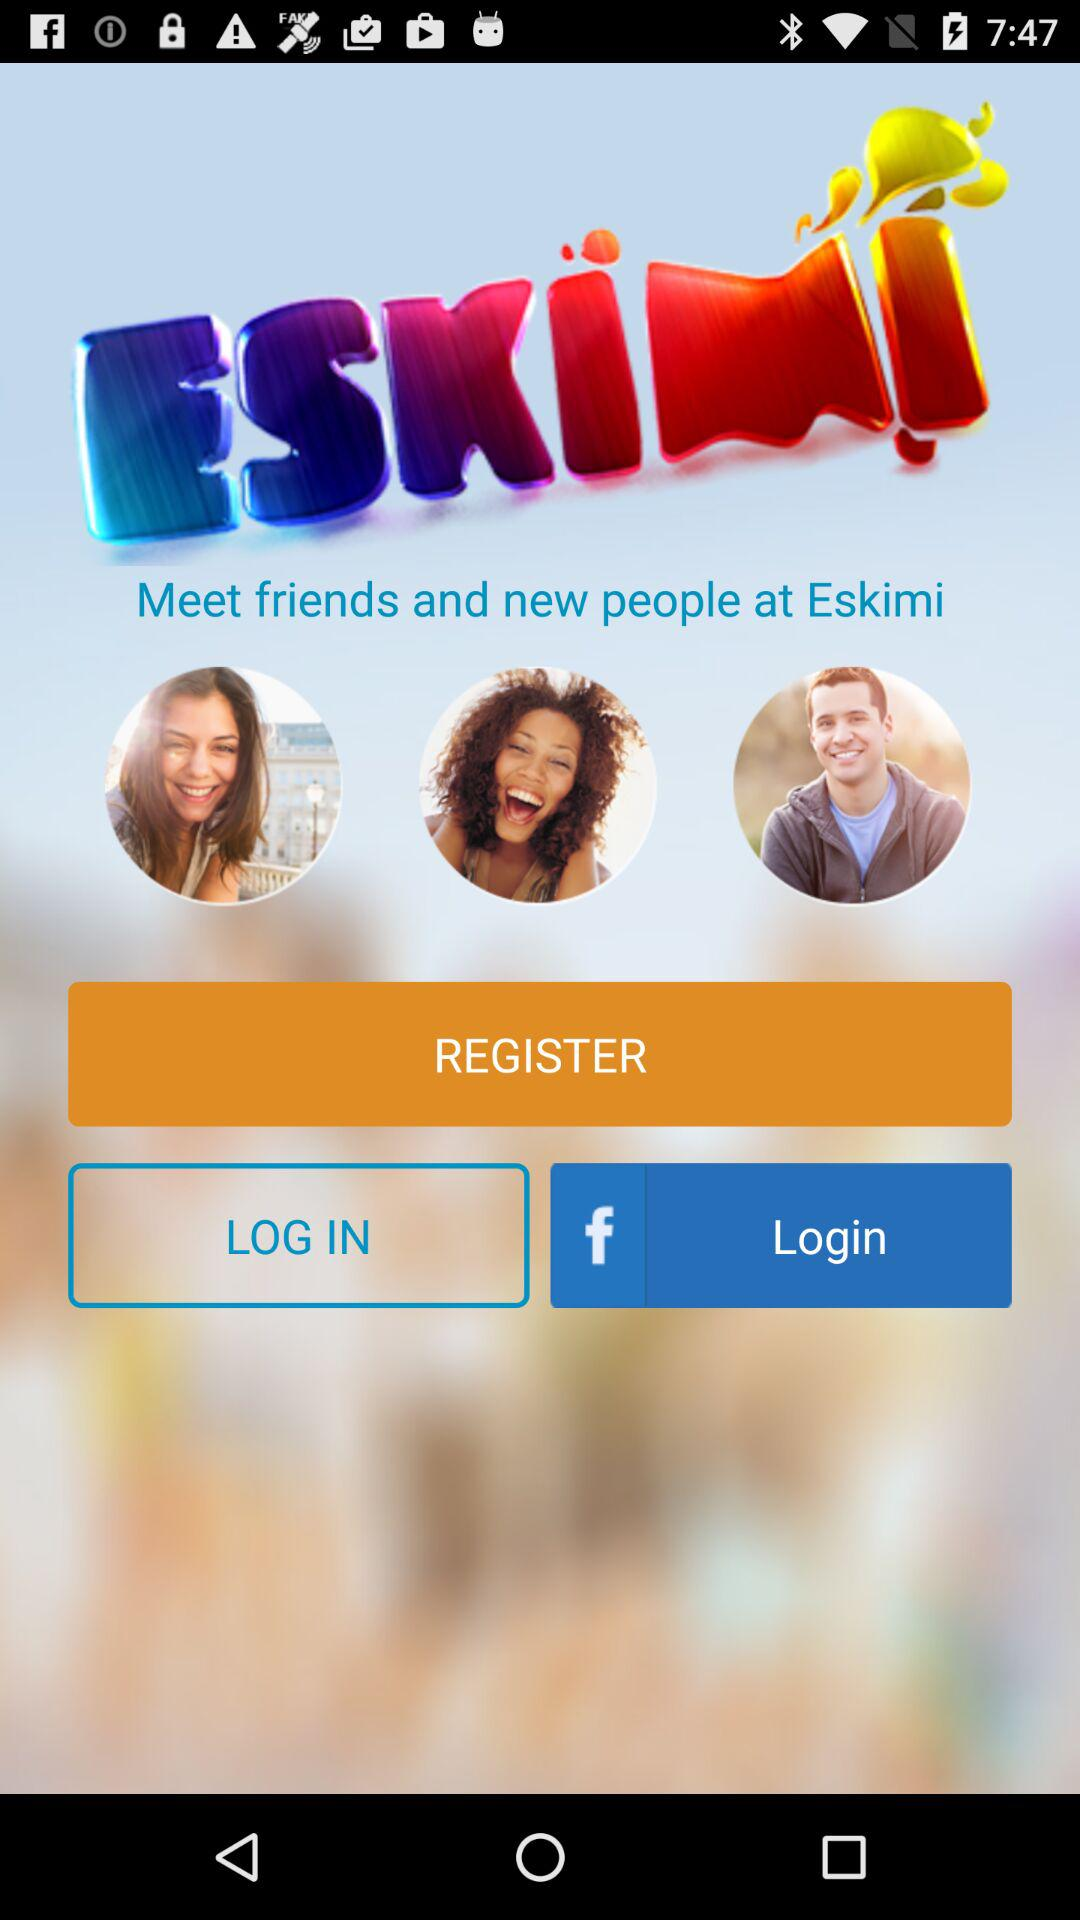What are the features of "Eskimi"? The feature is "Meet friends and new people at Eskimi". 